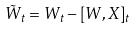<formula> <loc_0><loc_0><loc_500><loc_500>\tilde { W } _ { t } = W _ { t } - [ W , X ] _ { t }</formula> 